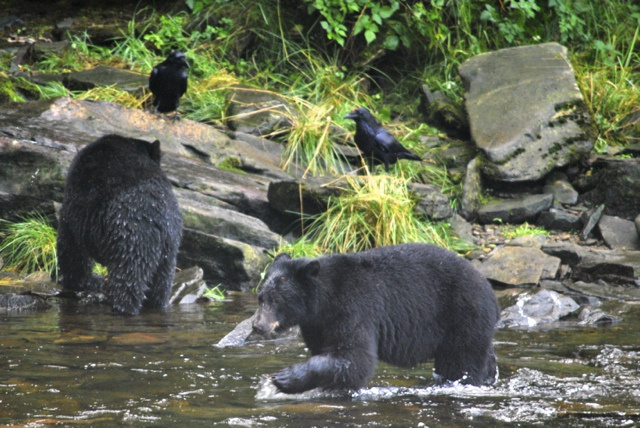Describe the objects in this image and their specific colors. I can see bear in black and gray tones, bear in black and gray tones, bird in black, gray, and olive tones, and bird in black, gray, and darkgreen tones in this image. 